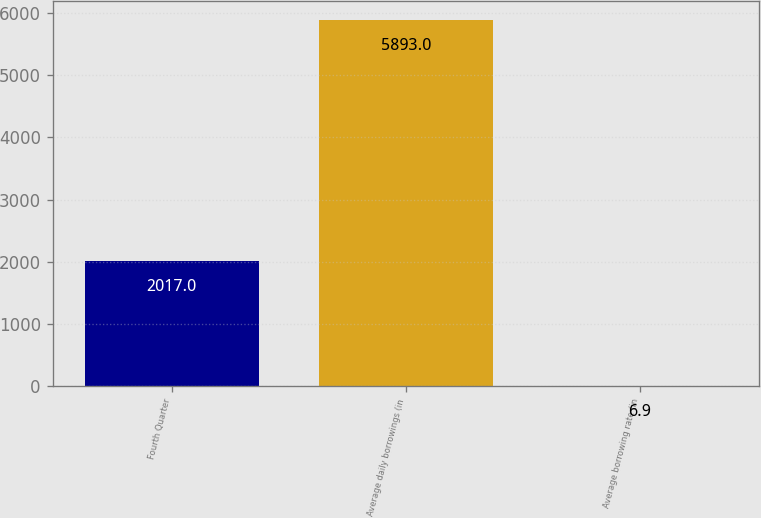Convert chart. <chart><loc_0><loc_0><loc_500><loc_500><bar_chart><fcel>Fourth Quarter<fcel>Average daily borrowings (in<fcel>Average borrowing rate (in<nl><fcel>2017<fcel>5893<fcel>6.9<nl></chart> 